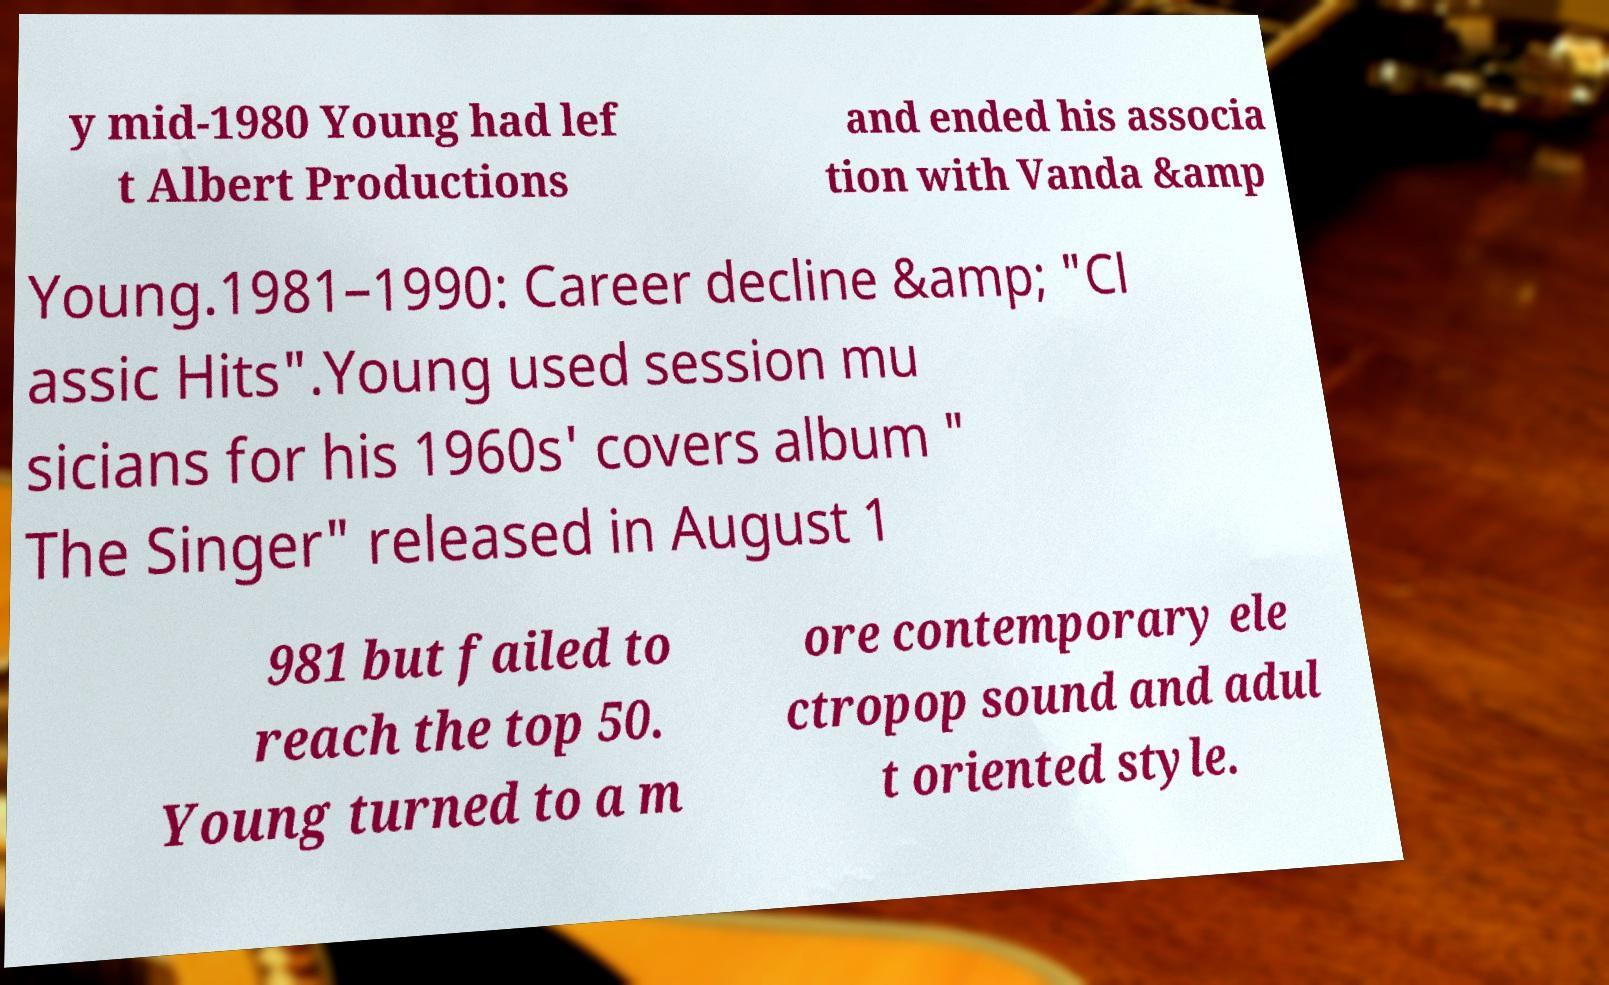I need the written content from this picture converted into text. Can you do that? y mid-1980 Young had lef t Albert Productions and ended his associa tion with Vanda &amp Young.1981–1990: Career decline &amp; "Cl assic Hits".Young used session mu sicians for his 1960s' covers album " The Singer" released in August 1 981 but failed to reach the top 50. Young turned to a m ore contemporary ele ctropop sound and adul t oriented style. 